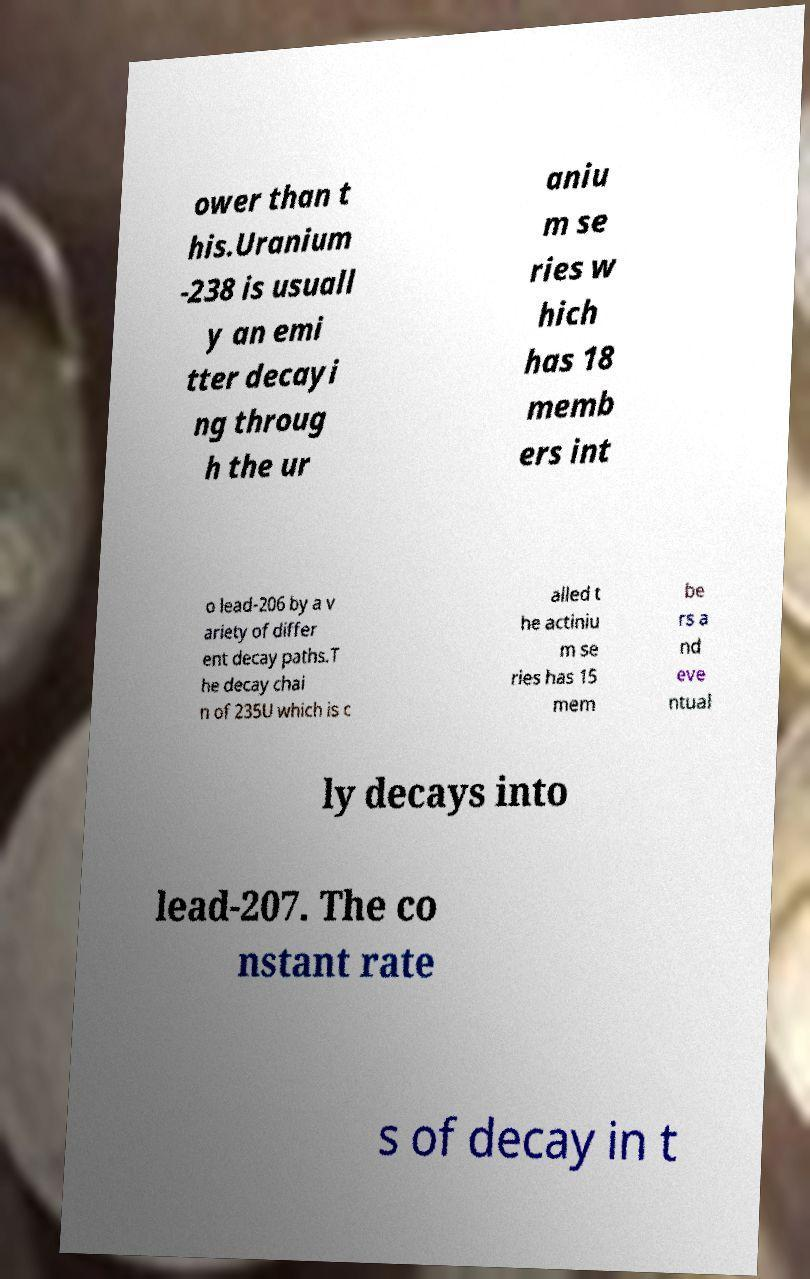What messages or text are displayed in this image? I need them in a readable, typed format. ower than t his.Uranium -238 is usuall y an emi tter decayi ng throug h the ur aniu m se ries w hich has 18 memb ers int o lead-206 by a v ariety of differ ent decay paths.T he decay chai n of 235U which is c alled t he actiniu m se ries has 15 mem be rs a nd eve ntual ly decays into lead-207. The co nstant rate s of decay in t 